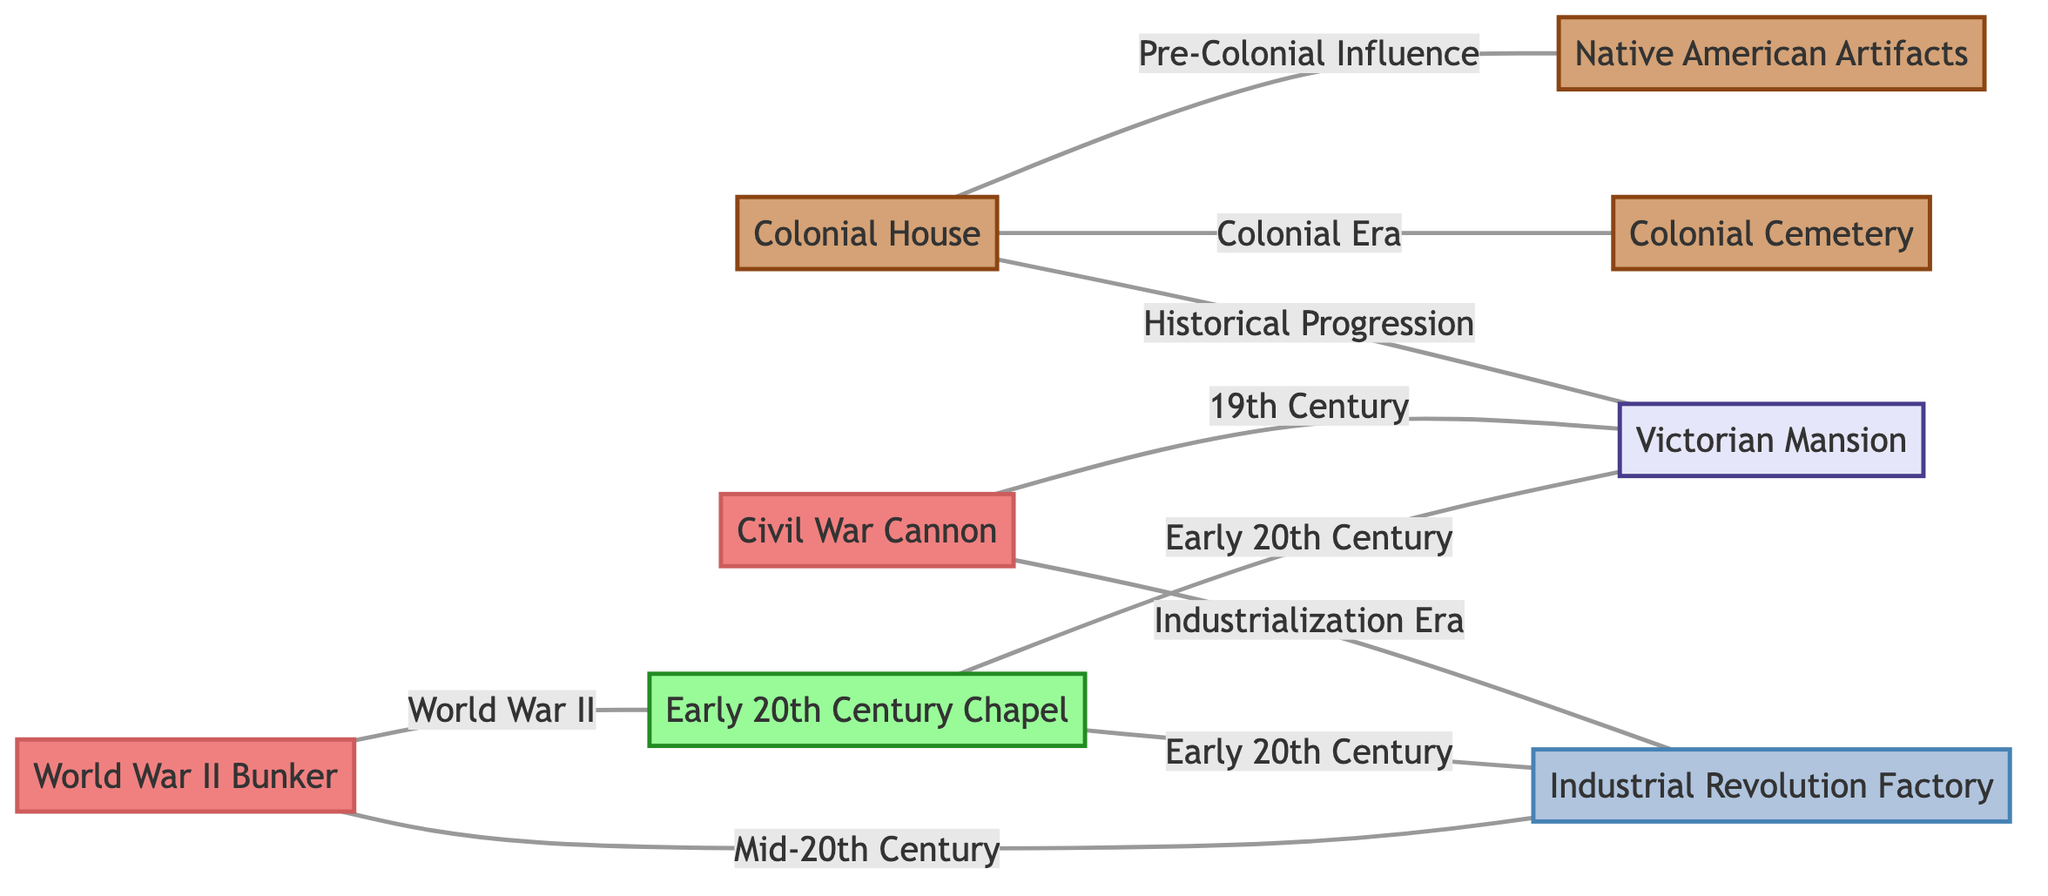What is the total number of nodes in the diagram? The diagram lists eight historical monuments and artifacts including Colonial House, Colonial Cemetery, Native American Artifacts, Victorian Mansion, Civil War Cannon, Industrial Revolution Factory, Early 20th Century Chapel, and World War II Bunker. Counting these gives a total of 8 nodes.
Answer: 8 What is the connection between the Colonial House and the Colonial Cemetery? The diagram indicates a direct edge between the Colonial House and the Colonial Cemetery labeled "Colonial Era", showing that they are related through this specific time period.
Answer: Colonial Era Which node has a relation to both the Civil War Cannon and the Industrial Revolution Factory? The Civil War Cannon has edges connecting it to both the Victorian Mansion labeled "19th Century" and the Industrial Revolution Factory labeled "Industrialization Era". Therefore, the Industrial Revolution Factory is the other node that connects through the Civil War Cannon.
Answer: Industrial Revolution Factory How many edges are connected to the Victorian Mansion? The Victorian Mansion is connected to three nodes: Colonial House, Civil War Cannon, and Early 20th Century Chapel. Counting these edges shows that the Victorian Mansion has three connections in total.
Answer: 3 What cultural influence is represented by the edges from the Colonial House to Native American Artifacts? The edge from the Colonial House to the Native American Artifacts is labeled "Pre-Colonial Influence", indicating that this connection represents influences from the time before colonialism.
Answer: Pre-Colonial Influence Which two nodes share a connection labeled "World War II"? The diagram shows that the World War II Bunker has an edge connecting it to the Early 20th Century Chapel, and this connection is specifically labeled "World War II". Therefore, these two nodes share this connection.
Answer: World War II Bunker and Early 20th Century Chapel Which historical era do the connections from the Civil War Cannon primarily represent? The edges from the Civil War Cannon primarily represent two historical contexts: "19th Century" to the Victorian Mansion and "Industrialization Era" to the Industrial Revolution Factory, indicating that the Civil War Cannon is related to both of these significant periods in history.
Answer: 19th Century and Industrialization Era How many nodes are connected to the Industrial Revolution Factory? The Industrial Revolution Factory has three direct connections: Civil War Cannon, Early 20th Century Chapel, and World War II Bunker, totaling three connections in the diagram.
Answer: 3 What type of artifacts influence are shown in relation to the Colonial House? The Colonial House shows influence from both "Colonial Era" regarding the Colonial Cemetery and "Pre-Colonial Influence" regarding the Native American Artifacts, establishing a connection back to earlier cultural artifacts.
Answer: Pre-Colonial Influence and Colonial Era 